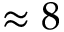Convert formula to latex. <formula><loc_0><loc_0><loc_500><loc_500>\approx 8</formula> 